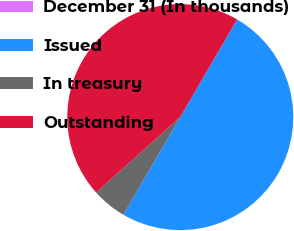<chart> <loc_0><loc_0><loc_500><loc_500><pie_chart><fcel>December 31 (In thousands)<fcel>Issued<fcel>In treasury<fcel>Outstanding<nl><fcel>0.01%<fcel>49.99%<fcel>4.99%<fcel>45.01%<nl></chart> 